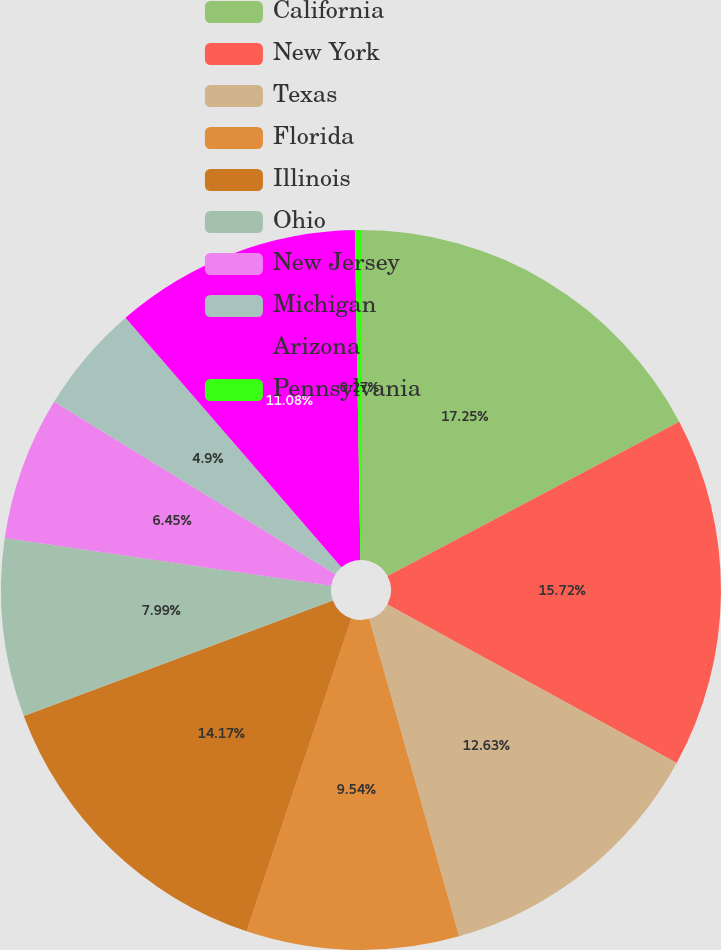Convert chart to OTSL. <chart><loc_0><loc_0><loc_500><loc_500><pie_chart><fcel>California<fcel>New York<fcel>Texas<fcel>Florida<fcel>Illinois<fcel>Ohio<fcel>New Jersey<fcel>Michigan<fcel>Arizona<fcel>Pennsylvania<nl><fcel>17.26%<fcel>15.72%<fcel>12.63%<fcel>9.54%<fcel>14.17%<fcel>7.99%<fcel>6.45%<fcel>4.9%<fcel>11.08%<fcel>0.27%<nl></chart> 